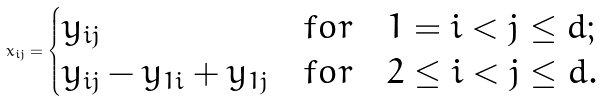<formula> <loc_0><loc_0><loc_500><loc_500>x _ { i j } = \begin{cases} y _ { i j } & f o r \quad 1 = i < j \leq d ; \\ y _ { i j } - y _ { 1 i } + y _ { 1 j } & f o r \quad 2 \leq i < j \leq d . \end{cases}</formula> 